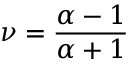Convert formula to latex. <formula><loc_0><loc_0><loc_500><loc_500>\nu = \frac { \alpha - 1 } { \alpha + 1 }</formula> 